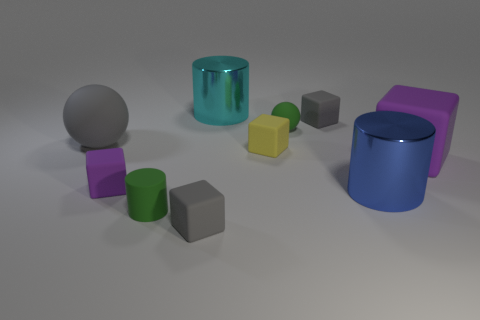Subtract all cyan cylinders. How many gray cubes are left? 2 Subtract all large cylinders. How many cylinders are left? 1 Subtract 1 cylinders. How many cylinders are left? 2 Subtract all gray blocks. How many blocks are left? 3 Subtract all cylinders. How many objects are left? 7 Subtract all green blocks. Subtract all yellow cylinders. How many blocks are left? 5 Add 7 tiny gray blocks. How many tiny gray blocks are left? 9 Add 8 brown metal blocks. How many brown metal blocks exist? 8 Subtract 2 gray blocks. How many objects are left? 8 Subtract all tiny things. Subtract all cyan things. How many objects are left? 3 